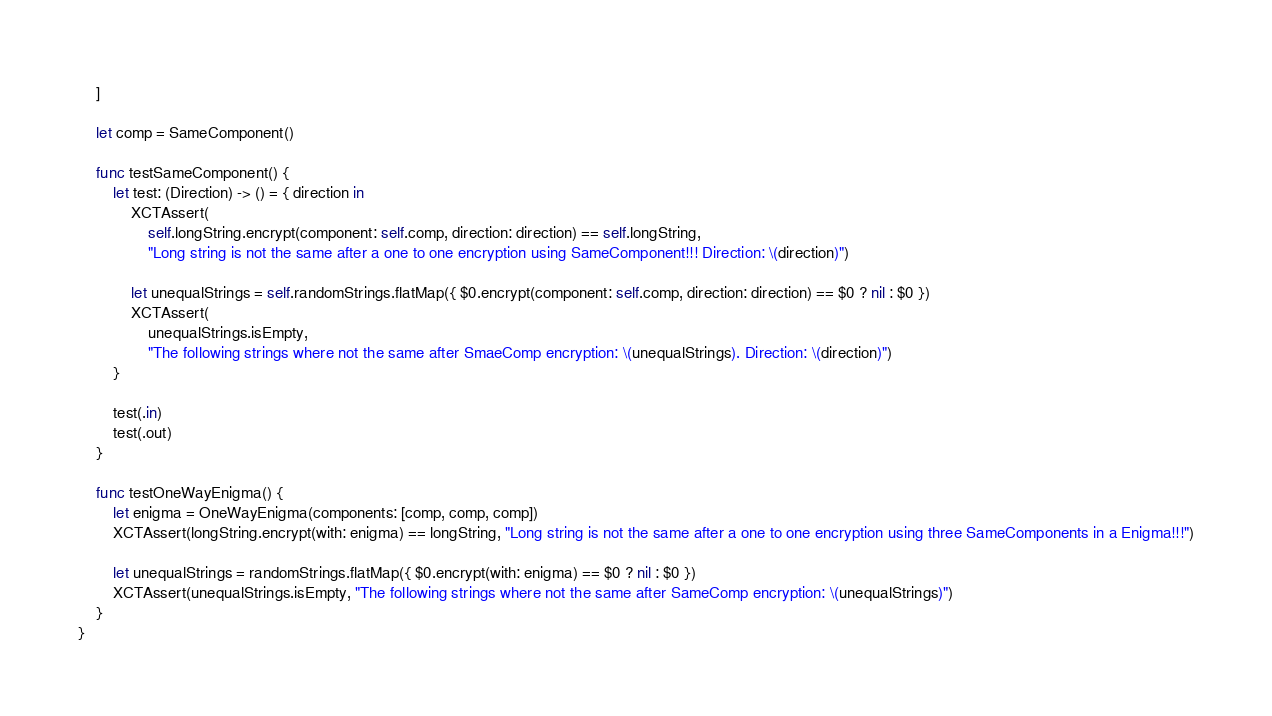Convert code to text. <code><loc_0><loc_0><loc_500><loc_500><_Swift_>    ]
    
    let comp = SameComponent()
    
    func testSameComponent() {
        let test: (Direction) -> () = { direction in
            XCTAssert(
                self.longString.encrypt(component: self.comp, direction: direction) == self.longString,
                "Long string is not the same after a one to one encryption using SameComponent!!! Direction: \(direction)")
            
            let unequalStrings = self.randomStrings.flatMap({ $0.encrypt(component: self.comp, direction: direction) == $0 ? nil : $0 })
            XCTAssert(
                unequalStrings.isEmpty,
                "The following strings where not the same after SmaeComp encryption: \(unequalStrings). Direction: \(direction)")
        }
        
        test(.in)
        test(.out)
    }
    
    func testOneWayEnigma() {
        let enigma = OneWayEnigma(components: [comp, comp, comp])
        XCTAssert(longString.encrypt(with: enigma) == longString, "Long string is not the same after a one to one encryption using three SameComponents in a Enigma!!!")
        
        let unequalStrings = randomStrings.flatMap({ $0.encrypt(with: enigma) == $0 ? nil : $0 })
        XCTAssert(unequalStrings.isEmpty, "The following strings where not the same after SameComp encryption: \(unequalStrings)")
    }
}
</code> 